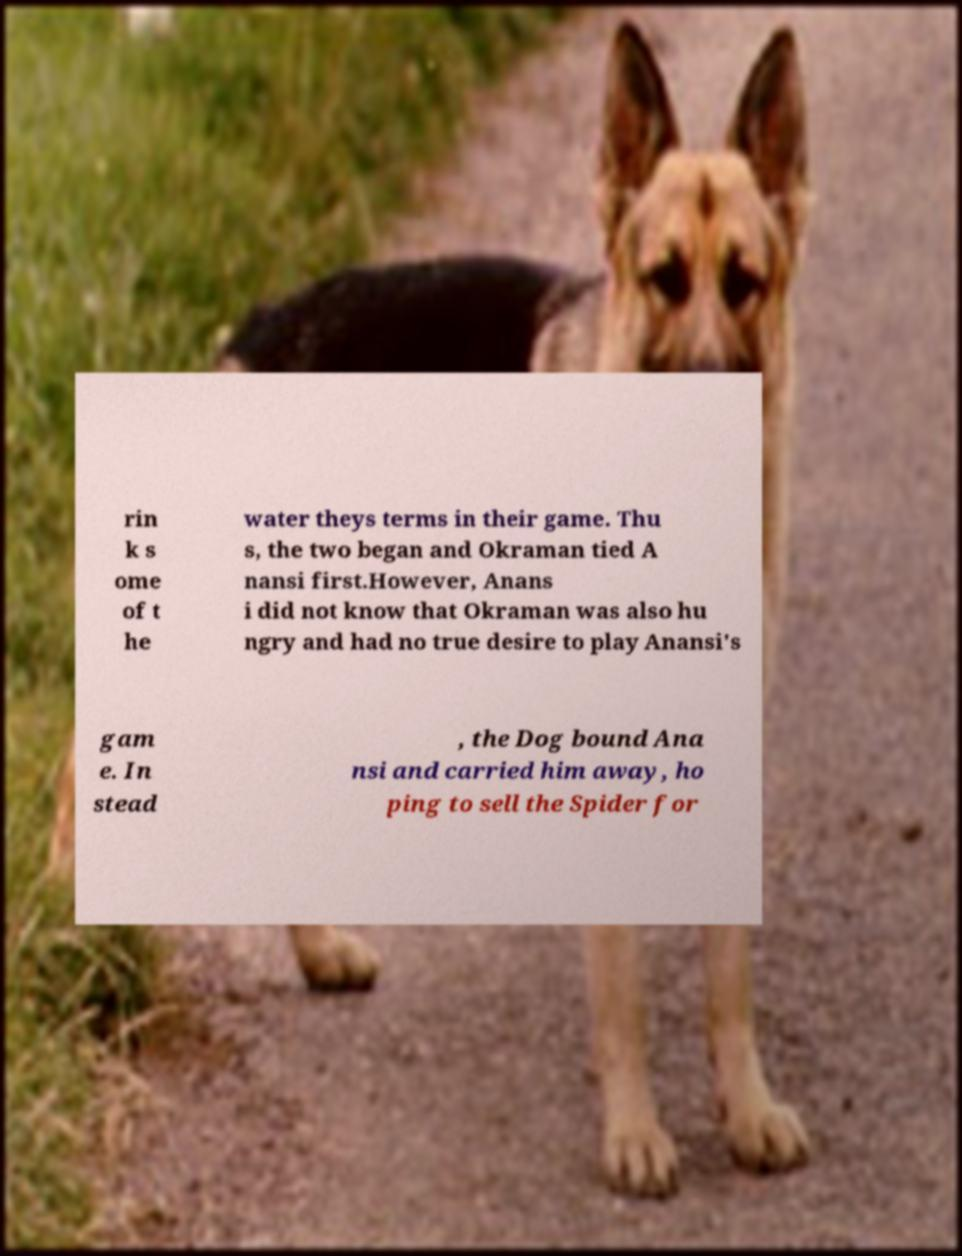What messages or text are displayed in this image? I need them in a readable, typed format. rin k s ome of t he water theys terms in their game. Thu s, the two began and Okraman tied A nansi first.However, Anans i did not know that Okraman was also hu ngry and had no true desire to play Anansi's gam e. In stead , the Dog bound Ana nsi and carried him away, ho ping to sell the Spider for 